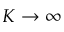Convert formula to latex. <formula><loc_0><loc_0><loc_500><loc_500>K \rightarrow \infty</formula> 